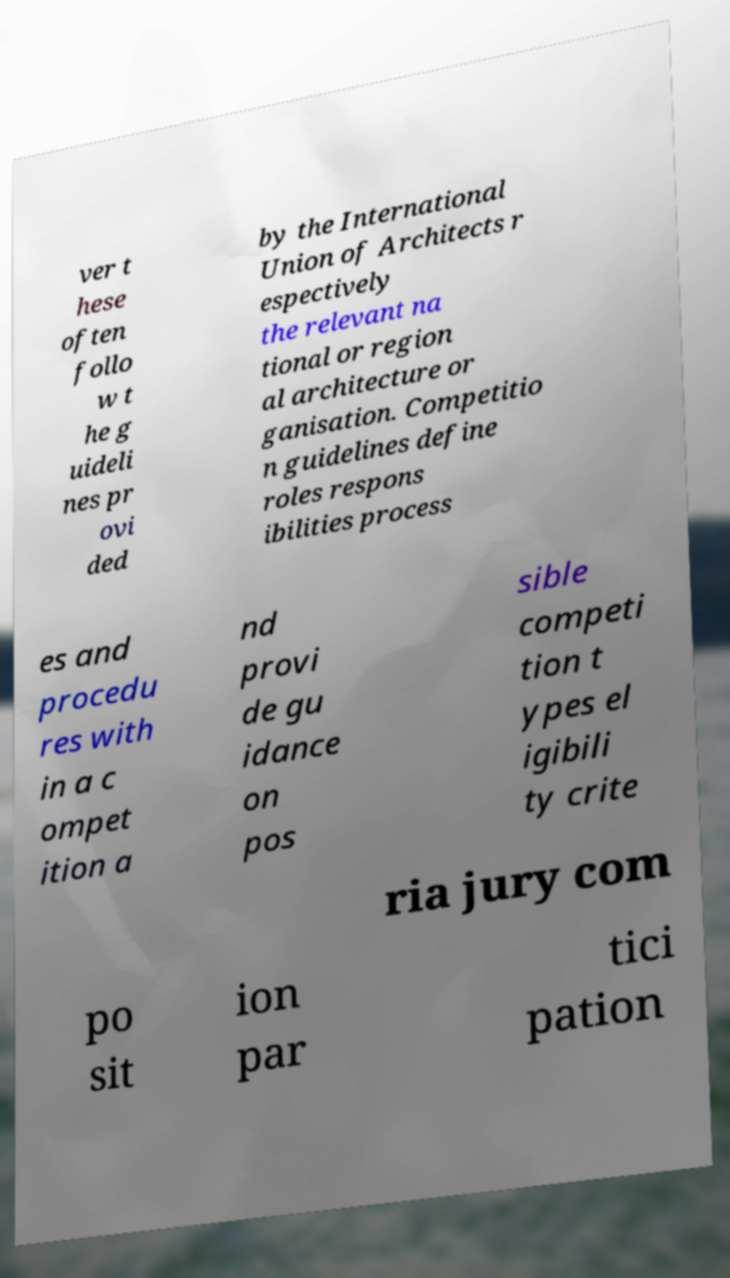For documentation purposes, I need the text within this image transcribed. Could you provide that? ver t hese often follo w t he g uideli nes pr ovi ded by the International Union of Architects r espectively the relevant na tional or region al architecture or ganisation. Competitio n guidelines define roles respons ibilities process es and procedu res with in a c ompet ition a nd provi de gu idance on pos sible competi tion t ypes el igibili ty crite ria jury com po sit ion par tici pation 